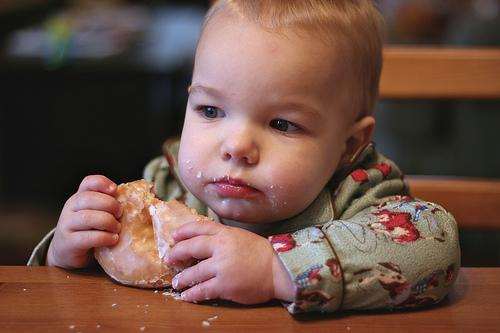Question: who is eating the donut?
Choices:
A. Toddler.
B. Billy.
C. The customer.
D. The girl.
Answer with the letter. Answer: A Question: what is the toddler wearing?
Choices:
A. Jeans.
B. A t-shirt.
C. Pajamas.
D. A coat.
Answer with the letter. Answer: C Question: why doe the toddler have crumbs on his face?
Choices:
A. Eating donut.
B. Cooking dinner.
C. Making faces.
D. Painting his face.
Answer with the letter. Answer: A Question: how many donuts?
Choices:
A. One.
B. Two.
C. Three.
D. Four.
Answer with the letter. Answer: A Question: where is the toddler sitting?
Choices:
A. Couch.
B. Bench.
C. Chair.
D. Table.
Answer with the letter. Answer: D Question: what type of table?
Choices:
A. Glass.
B. Plastic.
C. Metal.
D. Wooden.
Answer with the letter. Answer: D 